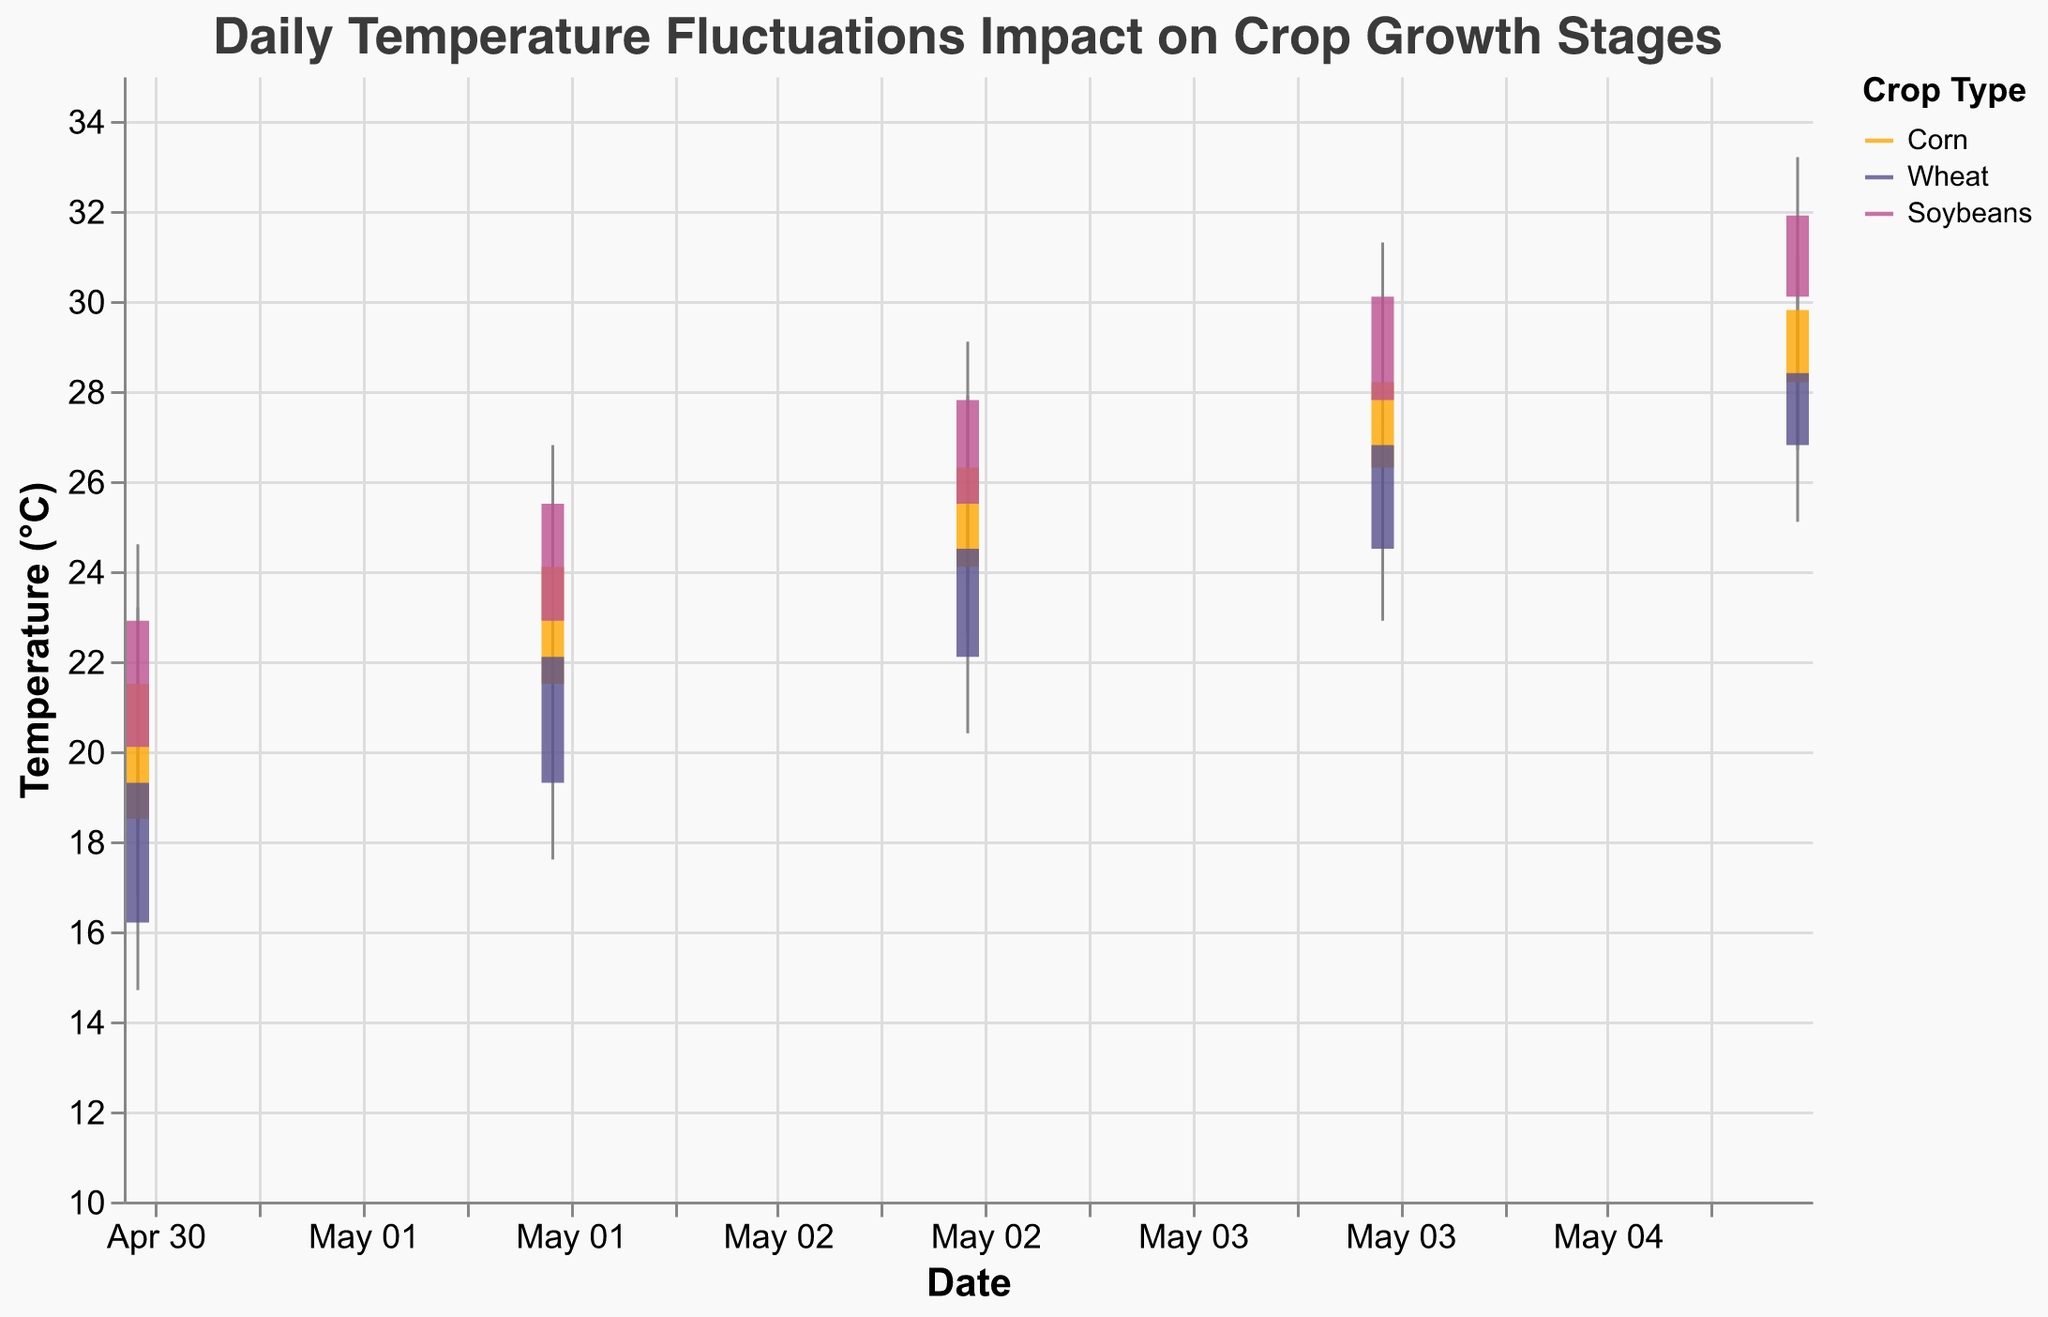What's the title of the figure? The title of the figure is usually displayed at the top of the chart, which in this case reads "Daily Temperature Fluctuations Impact on Crop Growth Stages"
Answer: Daily Temperature Fluctuations Impact on Crop Growth Stages Which crop has the highest closing temperature on any date? Checking the closing temperatures for each crop shows that Soybeans have the highest closing temperature (31.9°C) on May 5, 2023
Answer: Soybeans What were the high and low temperatures for Wheat on May 3rd? Find the data point for Wheat on May 3rd and read the high (25.9°C) and low (20.4°C) temperatures
Answer: 25.9°C and 20.4°C Which day had the largest temperature range for Corn and what was it? Calculate the temperature range (High - Low) for each day; for Corn, May 3rd had the largest range which is (27.9 - 22.6) = 5.3°C
Answer: May 3rd, 5.3°C What was the average closing temperature for Corn between May 1 and May 5? Calculate the average by adding the closing temperatures (21.5 + 24.1 + 26.3 + 28.2 + 29.8) and dividing by the number of days (5), the average is (129.9 / 5) = 25.98°C
Answer: 25.98°C On which day did Soybeans experience the least change in temperature? Calculate the temperature change for Soybeans on each day as (High - Low); May 1st had the smallest change (24.6 - 18.3) = 6.3°C
Answer: May 1st Which crop and on which date had the highest temperature recorded? The highest temperature among all data points is found in Soybeans on May 5 with 33.2°C
Answer: Soybeans, May 5 What was the trend in closing temperatures for Wheat from May 1 to May 5? Observe the closing temperatures for Wheat: May 1 is 19.3°C, May 2 is 22.1°C, May 3 is 24.5°C, May 4 is 26.8°C, and May 5 is 28.4°C, showing an increasing trend
Answer: Increasing trend Which crop had the most consistent closing temperatures over the given dates? Evaluate the fluctuations in closing temperatures for each crop; Corn has the smallest range of closing temperatures (21.5 to 29.8°C), indicating more consistency
Answer: Corn 